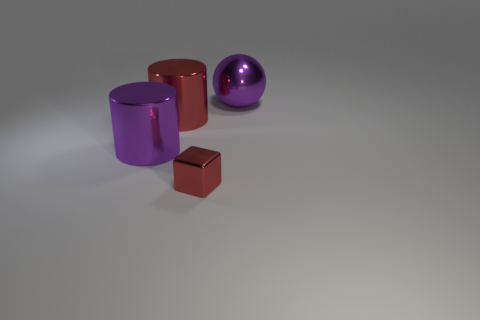Add 3 tiny red blocks. How many objects exist? 7 Subtract all balls. How many objects are left? 3 Add 4 large purple cylinders. How many large purple cylinders are left? 5 Add 1 metal objects. How many metal objects exist? 5 Subtract 0 gray blocks. How many objects are left? 4 Subtract all purple balls. Subtract all big yellow metal spheres. How many objects are left? 3 